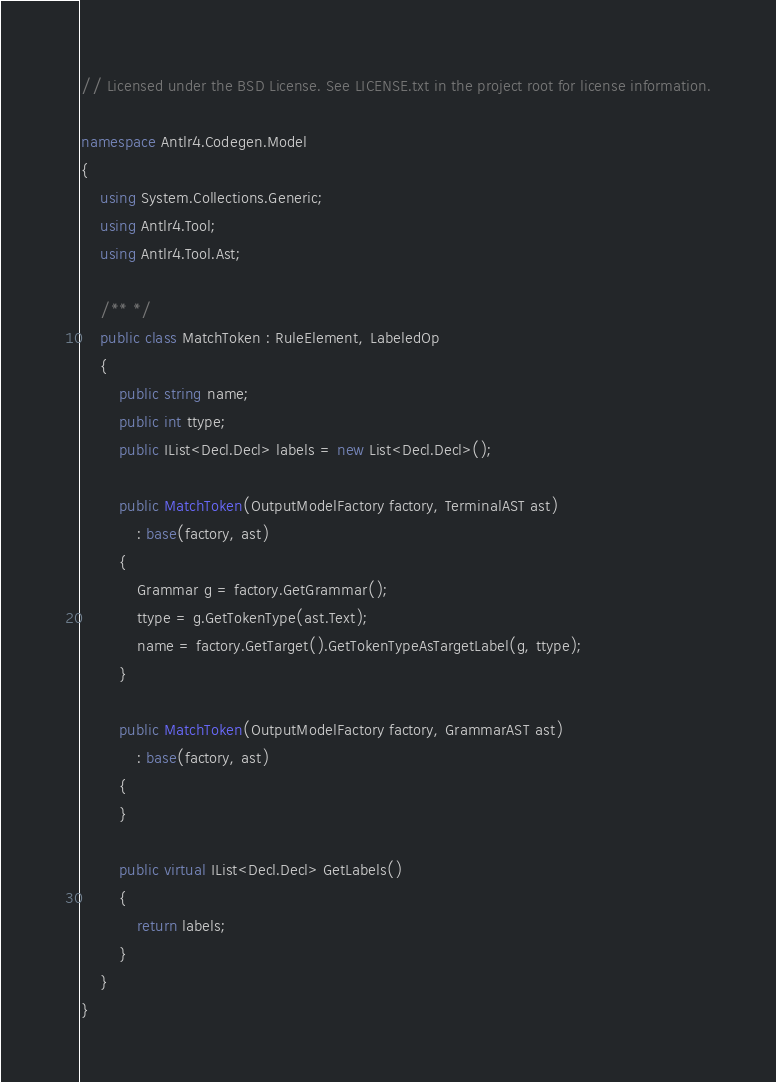<code> <loc_0><loc_0><loc_500><loc_500><_C#_>// Licensed under the BSD License. See LICENSE.txt in the project root for license information.

namespace Antlr4.Codegen.Model
{
    using System.Collections.Generic;
    using Antlr4.Tool;
    using Antlr4.Tool.Ast;

    /** */
    public class MatchToken : RuleElement, LabeledOp
    {
        public string name;
        public int ttype;
        public IList<Decl.Decl> labels = new List<Decl.Decl>();

        public MatchToken(OutputModelFactory factory, TerminalAST ast)
            : base(factory, ast)
        {
            Grammar g = factory.GetGrammar();
            ttype = g.GetTokenType(ast.Text);
            name = factory.GetTarget().GetTokenTypeAsTargetLabel(g, ttype);
        }

        public MatchToken(OutputModelFactory factory, GrammarAST ast)
            : base(factory, ast)
        {
        }

        public virtual IList<Decl.Decl> GetLabels()
        {
            return labels;
        }
    }
}
</code> 